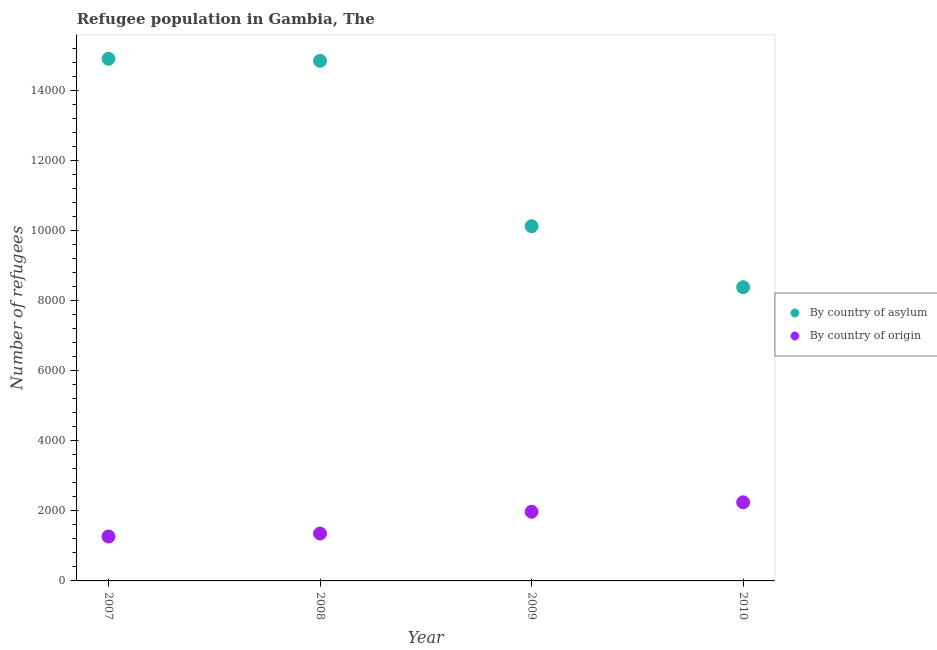How many different coloured dotlines are there?
Ensure brevity in your answer.  2. Is the number of dotlines equal to the number of legend labels?
Give a very brief answer. Yes. What is the number of refugees by country of origin in 2009?
Offer a very short reply. 1973. Across all years, what is the maximum number of refugees by country of asylum?
Provide a succinct answer. 1.49e+04. Across all years, what is the minimum number of refugees by country of origin?
Offer a very short reply. 1267. In which year was the number of refugees by country of asylum minimum?
Provide a short and direct response. 2010. What is the total number of refugees by country of asylum in the graph?
Ensure brevity in your answer.  4.82e+04. What is the difference between the number of refugees by country of asylum in 2008 and that in 2009?
Give a very brief answer. 4718. What is the difference between the number of refugees by country of asylum in 2007 and the number of refugees by country of origin in 2009?
Give a very brief answer. 1.29e+04. What is the average number of refugees by country of origin per year?
Make the answer very short. 1708.5. In the year 2008, what is the difference between the number of refugees by country of asylum and number of refugees by country of origin?
Your answer should be very brief. 1.35e+04. In how many years, is the number of refugees by country of asylum greater than 1200?
Offer a very short reply. 4. What is the ratio of the number of refugees by country of asylum in 2009 to that in 2010?
Keep it short and to the point. 1.21. Is the number of refugees by country of origin in 2008 less than that in 2009?
Your answer should be very brief. Yes. Is the difference between the number of refugees by country of origin in 2009 and 2010 greater than the difference between the number of refugees by country of asylum in 2009 and 2010?
Provide a succinct answer. No. What is the difference between the highest and the second highest number of refugees by country of origin?
Make the answer very short. 269. What is the difference between the highest and the lowest number of refugees by country of asylum?
Keep it short and to the point. 6517. How many dotlines are there?
Offer a very short reply. 2. Does the graph contain grids?
Make the answer very short. No. How are the legend labels stacked?
Make the answer very short. Vertical. What is the title of the graph?
Keep it short and to the point. Refugee population in Gambia, The. What is the label or title of the X-axis?
Offer a terse response. Year. What is the label or title of the Y-axis?
Offer a very short reply. Number of refugees. What is the Number of refugees of By country of asylum in 2007?
Keep it short and to the point. 1.49e+04. What is the Number of refugees in By country of origin in 2007?
Offer a very short reply. 1267. What is the Number of refugees in By country of asylum in 2008?
Ensure brevity in your answer.  1.48e+04. What is the Number of refugees in By country of origin in 2008?
Offer a very short reply. 1352. What is the Number of refugees in By country of asylum in 2009?
Keep it short and to the point. 1.01e+04. What is the Number of refugees in By country of origin in 2009?
Offer a terse response. 1973. What is the Number of refugees in By country of asylum in 2010?
Ensure brevity in your answer.  8378. What is the Number of refugees of By country of origin in 2010?
Your answer should be compact. 2242. Across all years, what is the maximum Number of refugees in By country of asylum?
Your answer should be compact. 1.49e+04. Across all years, what is the maximum Number of refugees in By country of origin?
Offer a very short reply. 2242. Across all years, what is the minimum Number of refugees of By country of asylum?
Your answer should be very brief. 8378. Across all years, what is the minimum Number of refugees in By country of origin?
Keep it short and to the point. 1267. What is the total Number of refugees of By country of asylum in the graph?
Your response must be concise. 4.82e+04. What is the total Number of refugees in By country of origin in the graph?
Keep it short and to the point. 6834. What is the difference between the Number of refugees in By country of asylum in 2007 and that in 2008?
Give a very brief answer. 59. What is the difference between the Number of refugees of By country of origin in 2007 and that in 2008?
Provide a short and direct response. -85. What is the difference between the Number of refugees in By country of asylum in 2007 and that in 2009?
Provide a short and direct response. 4777. What is the difference between the Number of refugees of By country of origin in 2007 and that in 2009?
Provide a succinct answer. -706. What is the difference between the Number of refugees in By country of asylum in 2007 and that in 2010?
Make the answer very short. 6517. What is the difference between the Number of refugees in By country of origin in 2007 and that in 2010?
Ensure brevity in your answer.  -975. What is the difference between the Number of refugees in By country of asylum in 2008 and that in 2009?
Provide a succinct answer. 4718. What is the difference between the Number of refugees in By country of origin in 2008 and that in 2009?
Your answer should be compact. -621. What is the difference between the Number of refugees of By country of asylum in 2008 and that in 2010?
Provide a succinct answer. 6458. What is the difference between the Number of refugees of By country of origin in 2008 and that in 2010?
Make the answer very short. -890. What is the difference between the Number of refugees of By country of asylum in 2009 and that in 2010?
Your answer should be very brief. 1740. What is the difference between the Number of refugees in By country of origin in 2009 and that in 2010?
Make the answer very short. -269. What is the difference between the Number of refugees in By country of asylum in 2007 and the Number of refugees in By country of origin in 2008?
Keep it short and to the point. 1.35e+04. What is the difference between the Number of refugees in By country of asylum in 2007 and the Number of refugees in By country of origin in 2009?
Offer a very short reply. 1.29e+04. What is the difference between the Number of refugees in By country of asylum in 2007 and the Number of refugees in By country of origin in 2010?
Provide a short and direct response. 1.27e+04. What is the difference between the Number of refugees of By country of asylum in 2008 and the Number of refugees of By country of origin in 2009?
Provide a short and direct response. 1.29e+04. What is the difference between the Number of refugees in By country of asylum in 2008 and the Number of refugees in By country of origin in 2010?
Provide a short and direct response. 1.26e+04. What is the difference between the Number of refugees of By country of asylum in 2009 and the Number of refugees of By country of origin in 2010?
Offer a very short reply. 7876. What is the average Number of refugees in By country of asylum per year?
Make the answer very short. 1.21e+04. What is the average Number of refugees in By country of origin per year?
Keep it short and to the point. 1708.5. In the year 2007, what is the difference between the Number of refugees of By country of asylum and Number of refugees of By country of origin?
Your response must be concise. 1.36e+04. In the year 2008, what is the difference between the Number of refugees of By country of asylum and Number of refugees of By country of origin?
Offer a very short reply. 1.35e+04. In the year 2009, what is the difference between the Number of refugees in By country of asylum and Number of refugees in By country of origin?
Give a very brief answer. 8145. In the year 2010, what is the difference between the Number of refugees in By country of asylum and Number of refugees in By country of origin?
Make the answer very short. 6136. What is the ratio of the Number of refugees of By country of origin in 2007 to that in 2008?
Offer a very short reply. 0.94. What is the ratio of the Number of refugees of By country of asylum in 2007 to that in 2009?
Keep it short and to the point. 1.47. What is the ratio of the Number of refugees in By country of origin in 2007 to that in 2009?
Your response must be concise. 0.64. What is the ratio of the Number of refugees of By country of asylum in 2007 to that in 2010?
Give a very brief answer. 1.78. What is the ratio of the Number of refugees of By country of origin in 2007 to that in 2010?
Keep it short and to the point. 0.57. What is the ratio of the Number of refugees in By country of asylum in 2008 to that in 2009?
Keep it short and to the point. 1.47. What is the ratio of the Number of refugees of By country of origin in 2008 to that in 2009?
Keep it short and to the point. 0.69. What is the ratio of the Number of refugees of By country of asylum in 2008 to that in 2010?
Provide a succinct answer. 1.77. What is the ratio of the Number of refugees in By country of origin in 2008 to that in 2010?
Your answer should be very brief. 0.6. What is the ratio of the Number of refugees in By country of asylum in 2009 to that in 2010?
Provide a short and direct response. 1.21. What is the ratio of the Number of refugees in By country of origin in 2009 to that in 2010?
Your answer should be compact. 0.88. What is the difference between the highest and the second highest Number of refugees of By country of asylum?
Your response must be concise. 59. What is the difference between the highest and the second highest Number of refugees of By country of origin?
Make the answer very short. 269. What is the difference between the highest and the lowest Number of refugees in By country of asylum?
Your response must be concise. 6517. What is the difference between the highest and the lowest Number of refugees in By country of origin?
Your answer should be compact. 975. 